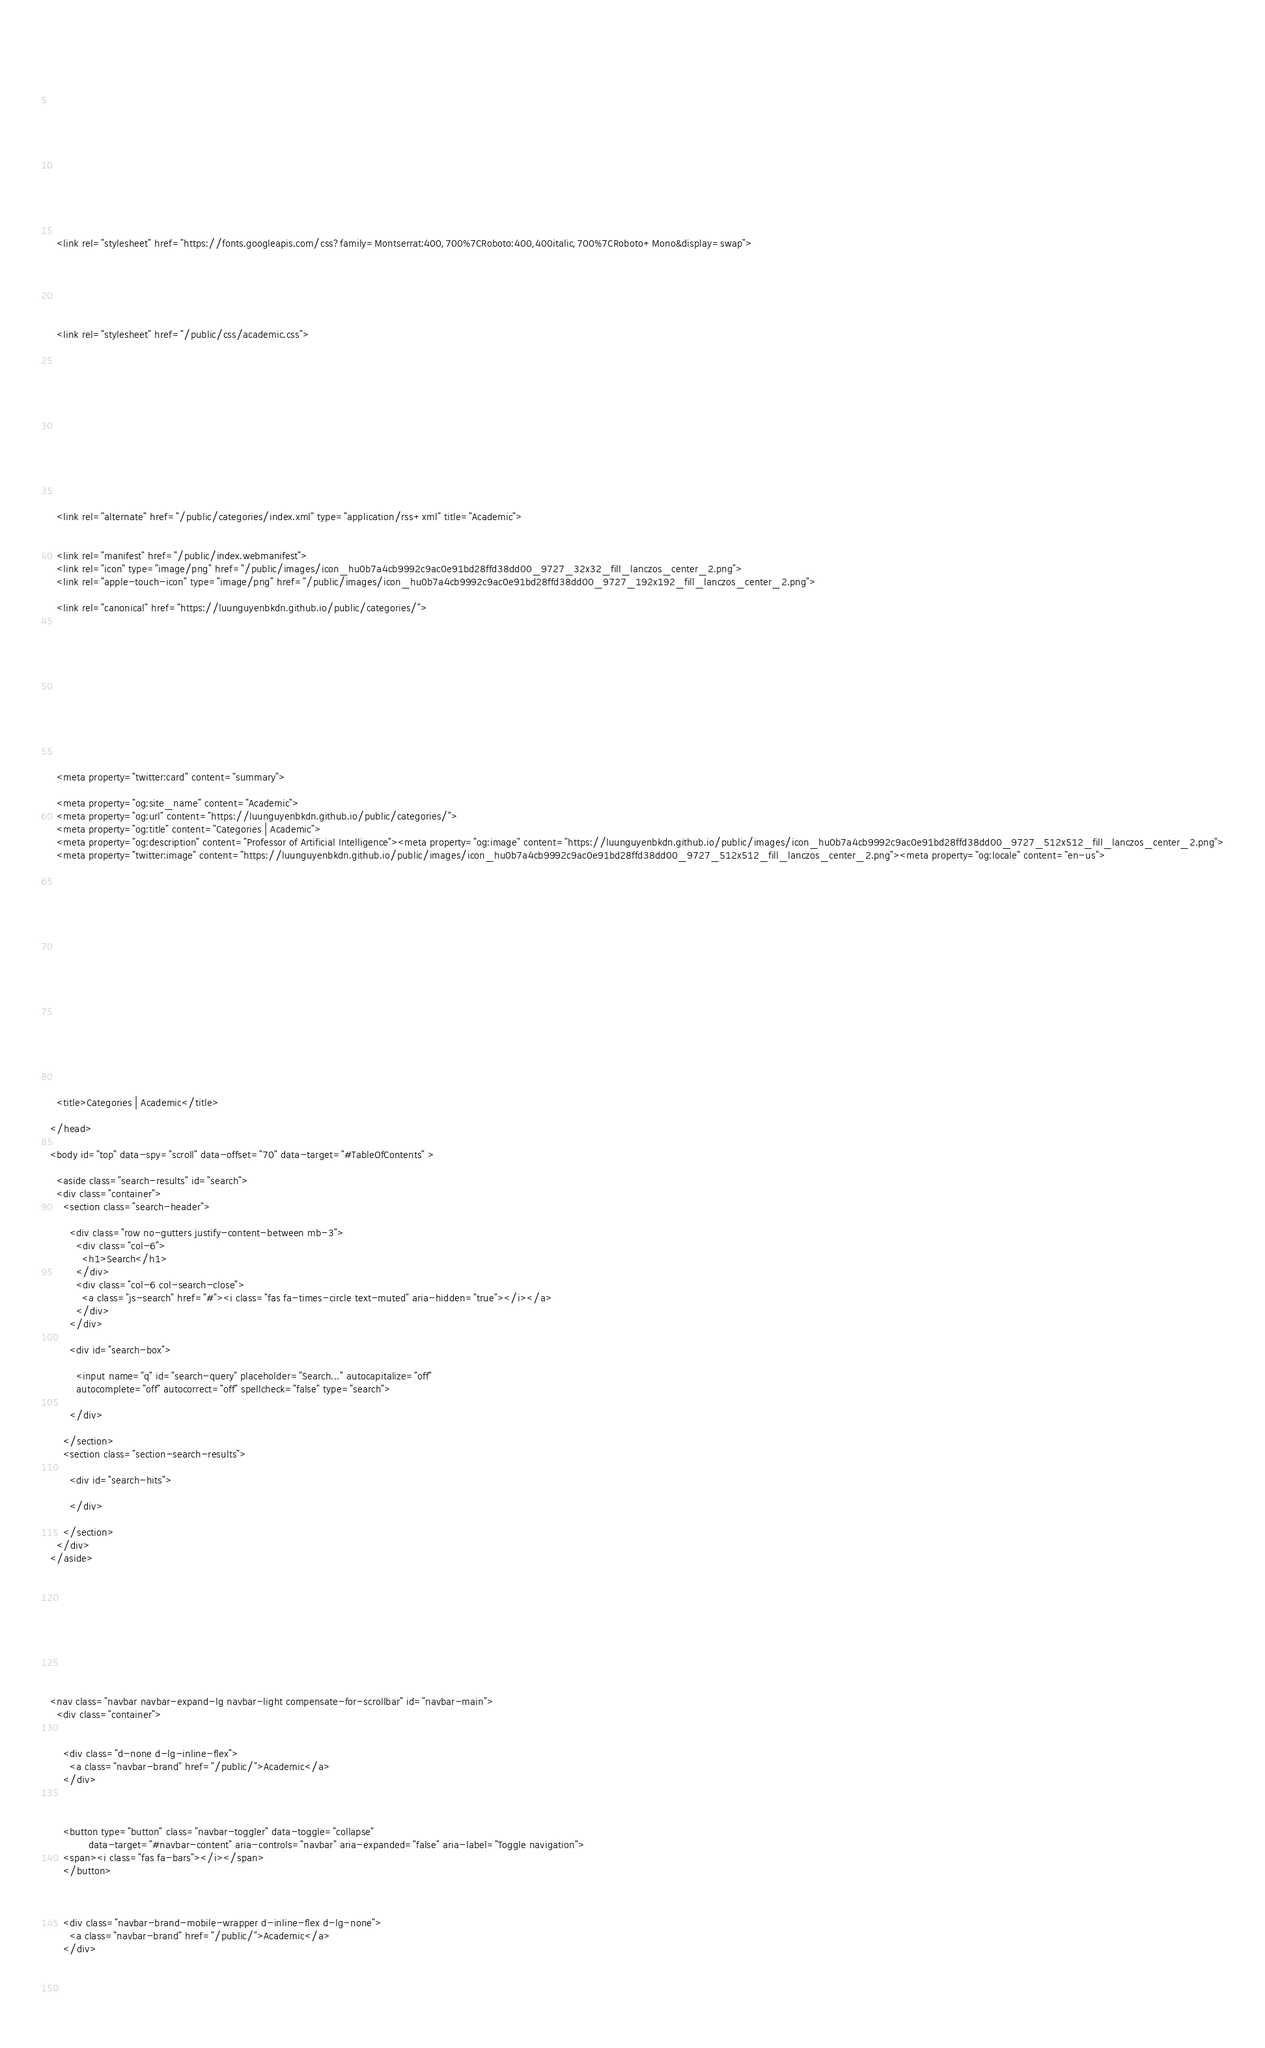Convert code to text. <code><loc_0><loc_0><loc_500><loc_500><_HTML_>
      
    
      

      
      

      
    

  

  
  
  
  <link rel="stylesheet" href="https://fonts.googleapis.com/css?family=Montserrat:400,700%7CRoboto:400,400italic,700%7CRoboto+Mono&display=swap">
  

  
  
  
  
  <link rel="stylesheet" href="/public/css/academic.css">

  




  


  
  

  
  <link rel="alternate" href="/public/categories/index.xml" type="application/rss+xml" title="Academic">
  

  <link rel="manifest" href="/public/index.webmanifest">
  <link rel="icon" type="image/png" href="/public/images/icon_hu0b7a4cb9992c9ac0e91bd28ffd38dd00_9727_32x32_fill_lanczos_center_2.png">
  <link rel="apple-touch-icon" type="image/png" href="/public/images/icon_hu0b7a4cb9992c9ac0e91bd28ffd38dd00_9727_192x192_fill_lanczos_center_2.png">

  <link rel="canonical" href="https://luunguyenbkdn.github.io/public/categories/">

  
  
  
  
  
  
  
    
    
  
  
  <meta property="twitter:card" content="summary">
  
  <meta property="og:site_name" content="Academic">
  <meta property="og:url" content="https://luunguyenbkdn.github.io/public/categories/">
  <meta property="og:title" content="Categories | Academic">
  <meta property="og:description" content="Professor of Artificial Intelligence"><meta property="og:image" content="https://luunguyenbkdn.github.io/public/images/icon_hu0b7a4cb9992c9ac0e91bd28ffd38dd00_9727_512x512_fill_lanczos_center_2.png">
  <meta property="twitter:image" content="https://luunguyenbkdn.github.io/public/images/icon_hu0b7a4cb9992c9ac0e91bd28ffd38dd00_9727_512x512_fill_lanczos_center_2.png"><meta property="og:locale" content="en-us">
  
    
  

  




  


  





  <title>Categories | Academic</title>

</head>

<body id="top" data-spy="scroll" data-offset="70" data-target="#TableOfContents" >

  <aside class="search-results" id="search">
  <div class="container">
    <section class="search-header">

      <div class="row no-gutters justify-content-between mb-3">
        <div class="col-6">
          <h1>Search</h1>
        </div>
        <div class="col-6 col-search-close">
          <a class="js-search" href="#"><i class="fas fa-times-circle text-muted" aria-hidden="true"></i></a>
        </div>
      </div>

      <div id="search-box">
        
        <input name="q" id="search-query" placeholder="Search..." autocapitalize="off"
        autocomplete="off" autocorrect="off" spellcheck="false" type="search">
        
      </div>

    </section>
    <section class="section-search-results">

      <div id="search-hits">
        
      </div>

    </section>
  </div>
</aside>


  







<nav class="navbar navbar-expand-lg navbar-light compensate-for-scrollbar" id="navbar-main">
  <div class="container">

    
    <div class="d-none d-lg-inline-flex">
      <a class="navbar-brand" href="/public/">Academic</a>
    </div>
    

    
    <button type="button" class="navbar-toggler" data-toggle="collapse"
            data-target="#navbar-content" aria-controls="navbar" aria-expanded="false" aria-label="Toggle navigation">
    <span><i class="fas fa-bars"></i></span>
    </button>
    

    
    <div class="navbar-brand-mobile-wrapper d-inline-flex d-lg-none">
      <a class="navbar-brand" href="/public/">Academic</a>
    </div>
    

    
    </code> 